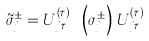<formula> <loc_0><loc_0><loc_500><loc_500>\tilde { \sigma } _ { j } ^ { \pm } = U _ { j \tau } ^ { \left ( \tau \right ) \dagger } \, \left ( \sigma _ { j } ^ { \pm } \right ) \, U _ { j \tau } ^ { \left ( \tau \right ) }</formula> 